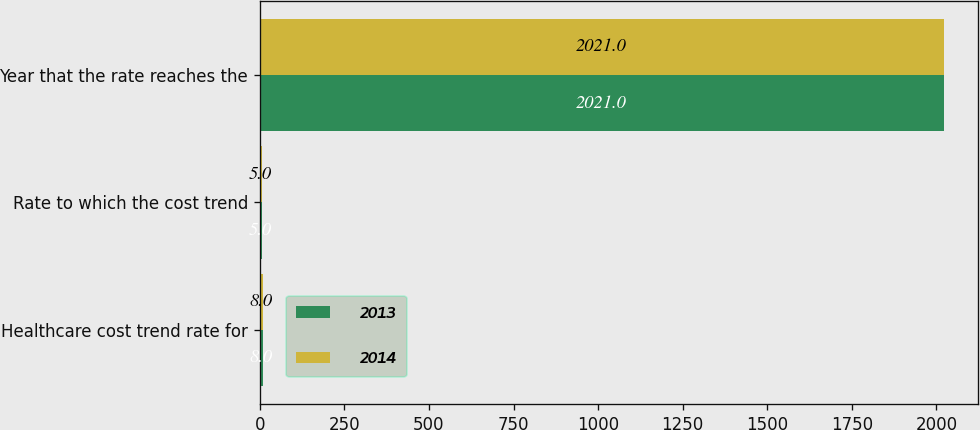Convert chart to OTSL. <chart><loc_0><loc_0><loc_500><loc_500><stacked_bar_chart><ecel><fcel>Healthcare cost trend rate for<fcel>Rate to which the cost trend<fcel>Year that the rate reaches the<nl><fcel>2013<fcel>8<fcel>5<fcel>2021<nl><fcel>2014<fcel>8<fcel>5<fcel>2021<nl></chart> 